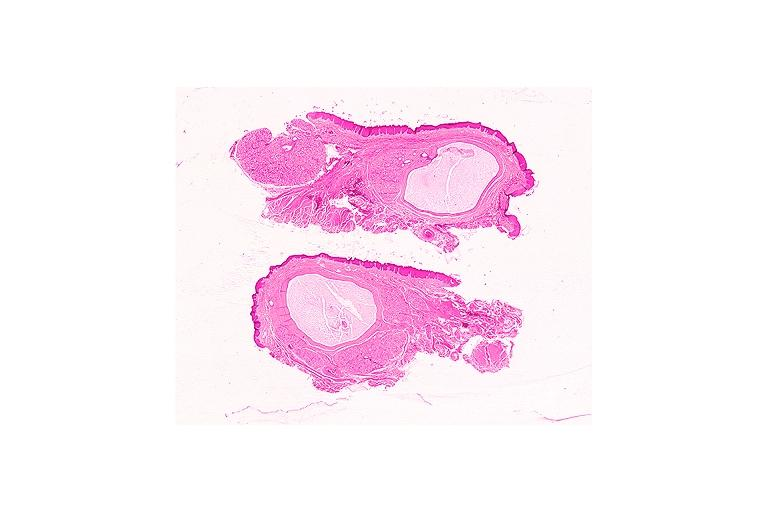s med immunostain for prostate specific antigen present?
Answer the question using a single word or phrase. No 